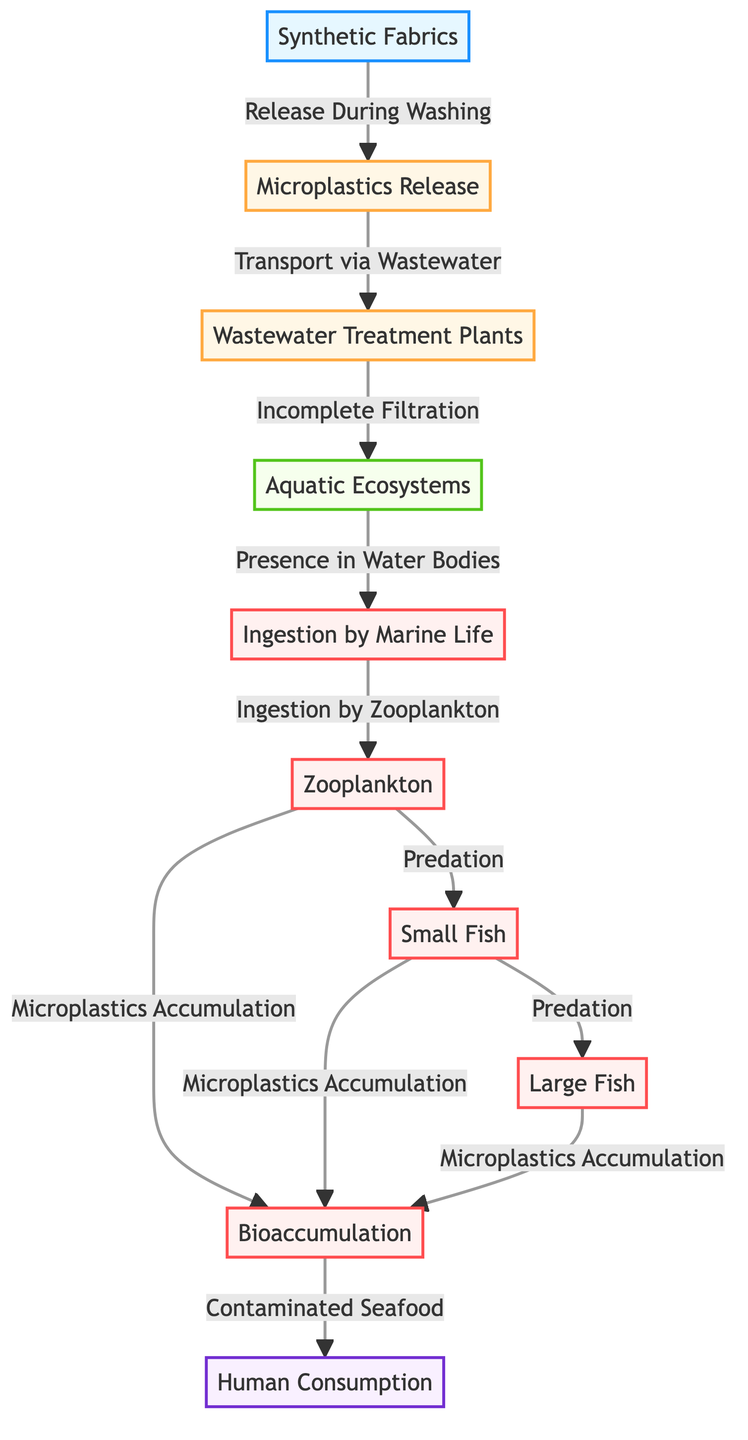What is the first node in the diagram? The first node represents a source of microplastics, which is "Synthetic Fabrics." It initiates the diagram's flow by releasing microplastics during washing, leading to further processes.
Answer: Synthetic Fabrics How many marine life categories are shown in the diagram? The diagram displays three categories of marine life: zooplankton, small fish, and large fish. Each of these nodes plays a role in the ingestion and bioaccumulation process.
Answer: Three What is the relationship between "Microplastics Release" and "Wastewater Treatment Plants"? "Microplastics Release" is connected to "Wastewater Treatment Plants" with the phrase "Transport via Wastewater." This indicates that microplastics released by synthetic fabrics are transported through wastewater systems to treatment plants.
Answer: Transport via Wastewater Which node represents the final human impact in the diagram? The final human impact is represented by the node "Human Consumption." It indicates the end point where humans may be affected by consuming contaminated seafood due to the bioaccumulation of microplastics.
Answer: Human Consumption What process is described between "Zooplankton" and "Small Fish"? The process described is "Predation," where small fish consume zooplankton, leading to the transfer of microplastics through the food chain.
Answer: Predation How does wastewater treatment contribute to microplastics in aquatic ecosystems? Wastewater treatment contributes through "Incomplete Filtration," which indicates that not all microplastics are filtered out and can enter aquatic ecosystems, impacting overall health.
Answer: Incomplete Filtration What do the nodes "Small Fish" and "Large Fish" signify in terms of bioaccumulation? Both "Small Fish" and "Large Fish" signify the continuation of microplastics accumulation through the food chain. They accumulate microplastics when consuming organisms below them in the chain.
Answer: Microplastics Accumulation What node follows "Aquatic Ecosystems" in the flow of microplastics? The node that follows "Aquatic Ecosystems" is "Ingestion," indicating that marine life begins to ingest microplastics that are present in their environment.
Answer: Ingestion 